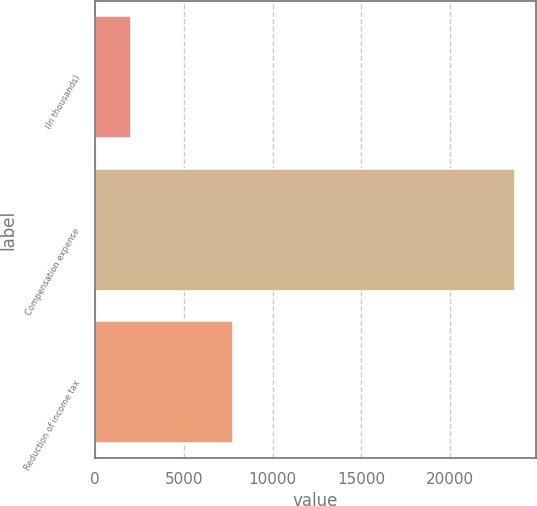Convert chart to OTSL. <chart><loc_0><loc_0><loc_500><loc_500><bar_chart><fcel>(In thousands)<fcel>Compensation expense<fcel>Reduction of income tax<nl><fcel>2014<fcel>23632<fcel>7767<nl></chart> 